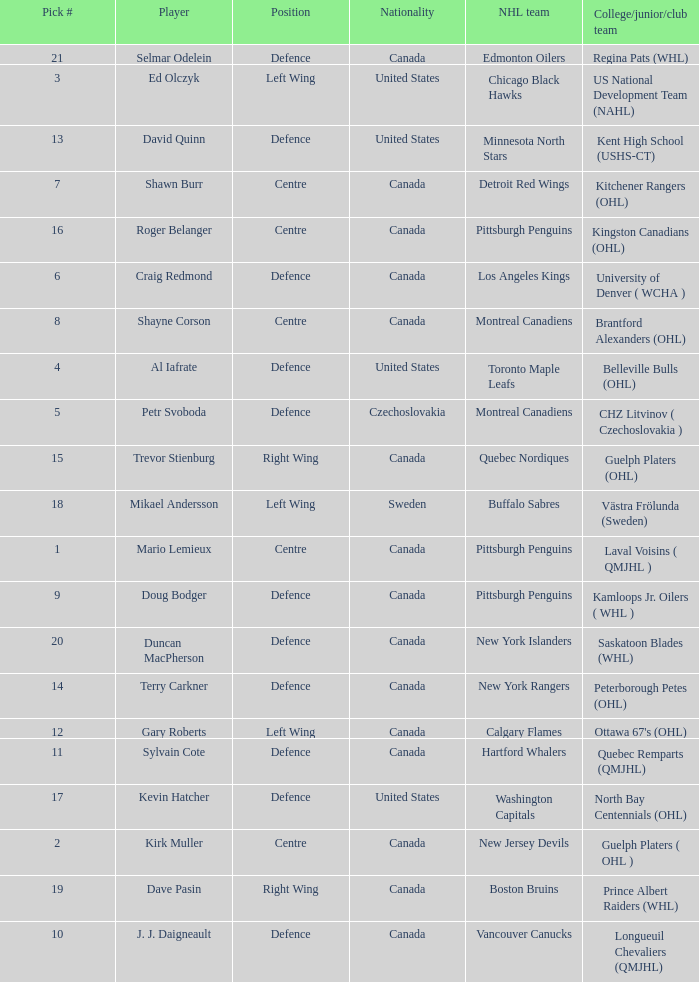What college team did draft pick 18 come from? Västra Frölunda (Sweden). 